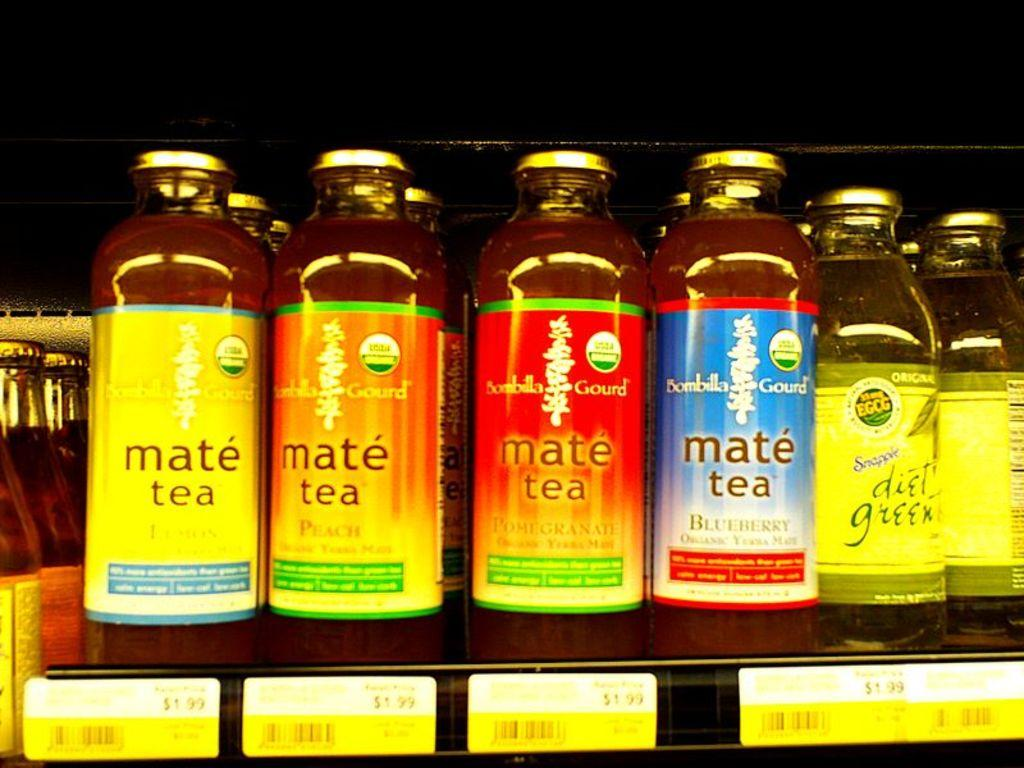<image>
Relay a brief, clear account of the picture shown. A few bottles of Mate Tea on a store shelf 